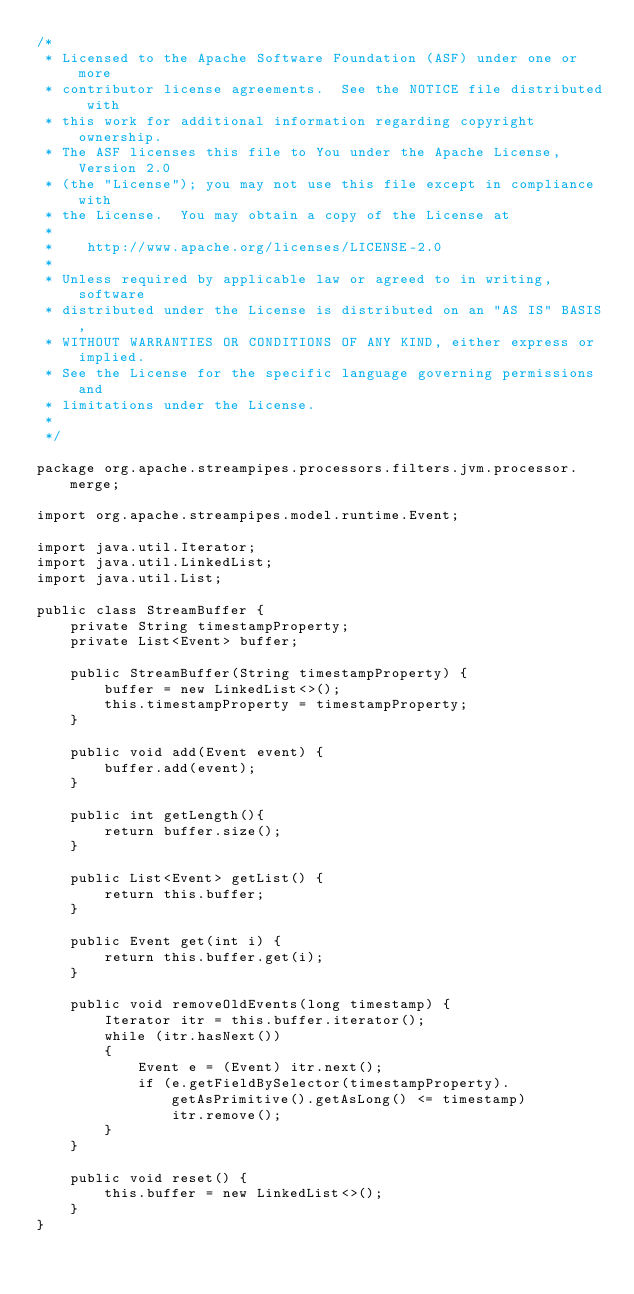Convert code to text. <code><loc_0><loc_0><loc_500><loc_500><_Java_>/*
 * Licensed to the Apache Software Foundation (ASF) under one or more
 * contributor license agreements.  See the NOTICE file distributed with
 * this work for additional information regarding copyright ownership.
 * The ASF licenses this file to You under the Apache License, Version 2.0
 * (the "License"); you may not use this file except in compliance with
 * the License.  You may obtain a copy of the License at
 *
 *    http://www.apache.org/licenses/LICENSE-2.0
 *
 * Unless required by applicable law or agreed to in writing, software
 * distributed under the License is distributed on an "AS IS" BASIS,
 * WITHOUT WARRANTIES OR CONDITIONS OF ANY KIND, either express or implied.
 * See the License for the specific language governing permissions and
 * limitations under the License.
 *
 */

package org.apache.streampipes.processors.filters.jvm.processor.merge;

import org.apache.streampipes.model.runtime.Event;

import java.util.Iterator;
import java.util.LinkedList;
import java.util.List;

public class StreamBuffer {
    private String timestampProperty;
    private List<Event> buffer;

    public StreamBuffer(String timestampProperty) {
        buffer = new LinkedList<>();
        this.timestampProperty = timestampProperty;
    }

    public void add(Event event) {
        buffer.add(event);
    }

    public int getLength(){
        return buffer.size();
    }

    public List<Event> getList() {
        return this.buffer;
    }

    public Event get(int i) {
        return this.buffer.get(i);
    }

    public void removeOldEvents(long timestamp) {
        Iterator itr = this.buffer.iterator();
        while (itr.hasNext())
        {
            Event e = (Event) itr.next();
            if (e.getFieldBySelector(timestampProperty).getAsPrimitive().getAsLong() <= timestamp)
                itr.remove();
        }
    }

    public void reset() {
        this.buffer = new LinkedList<>();
    }
}
</code> 